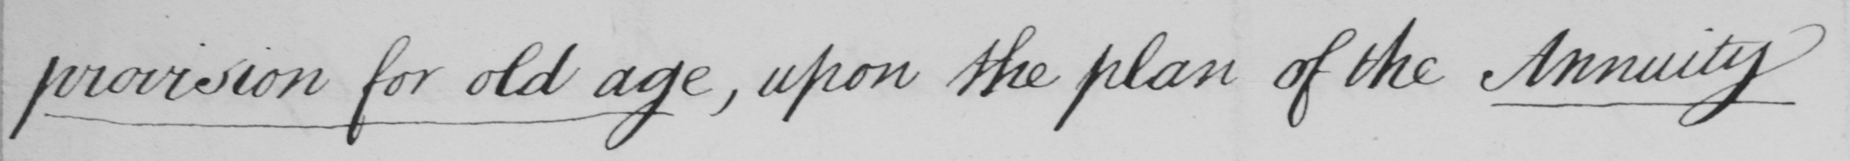Can you read and transcribe this handwriting? provision for old age , upon the plan of the Annuity 